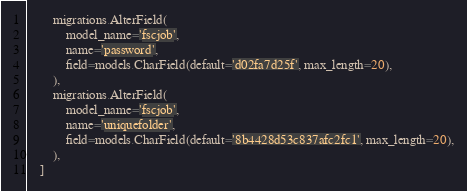<code> <loc_0><loc_0><loc_500><loc_500><_Python_>        migrations.AlterField(
            model_name='fscjob',
            name='password',
            field=models.CharField(default='d02fa7d25f', max_length=20),
        ),
        migrations.AlterField(
            model_name='fscjob',
            name='uniquefolder',
            field=models.CharField(default='8b4428d53c837afc2fc1', max_length=20),
        ),
    ]
</code> 